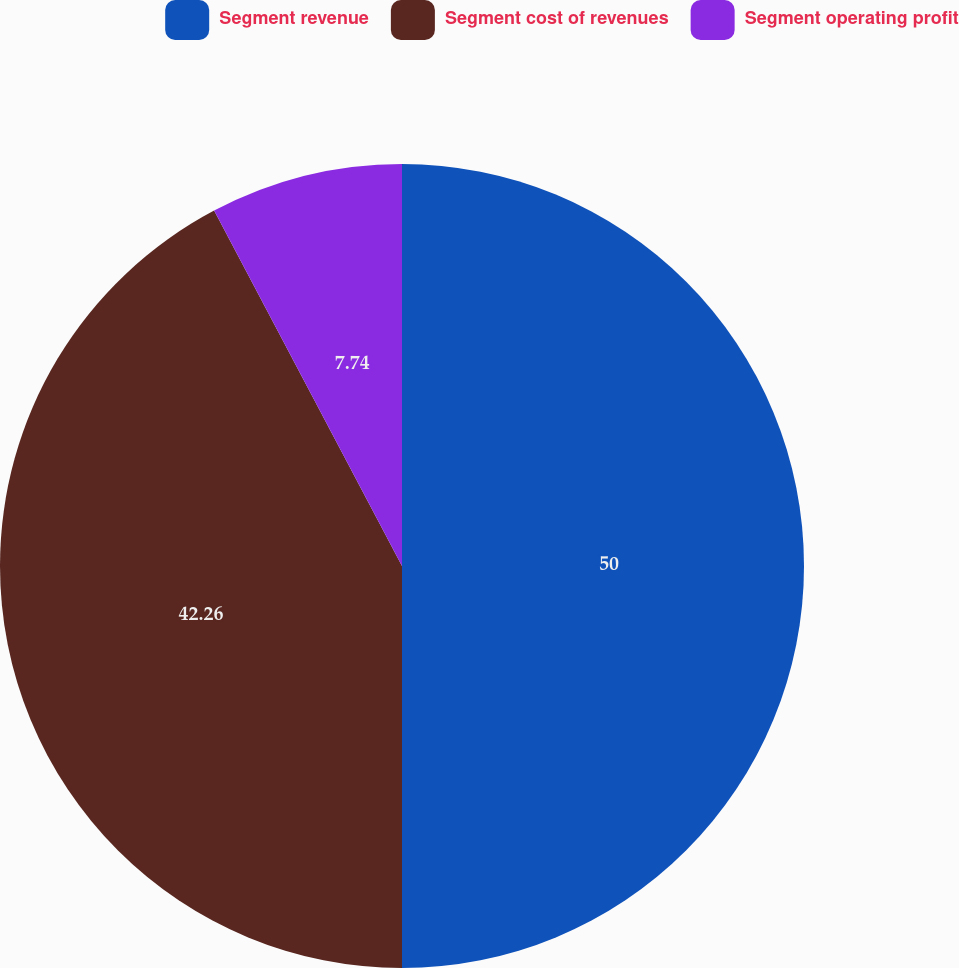Convert chart to OTSL. <chart><loc_0><loc_0><loc_500><loc_500><pie_chart><fcel>Segment revenue<fcel>Segment cost of revenues<fcel>Segment operating profit<nl><fcel>50.0%<fcel>42.26%<fcel>7.74%<nl></chart> 